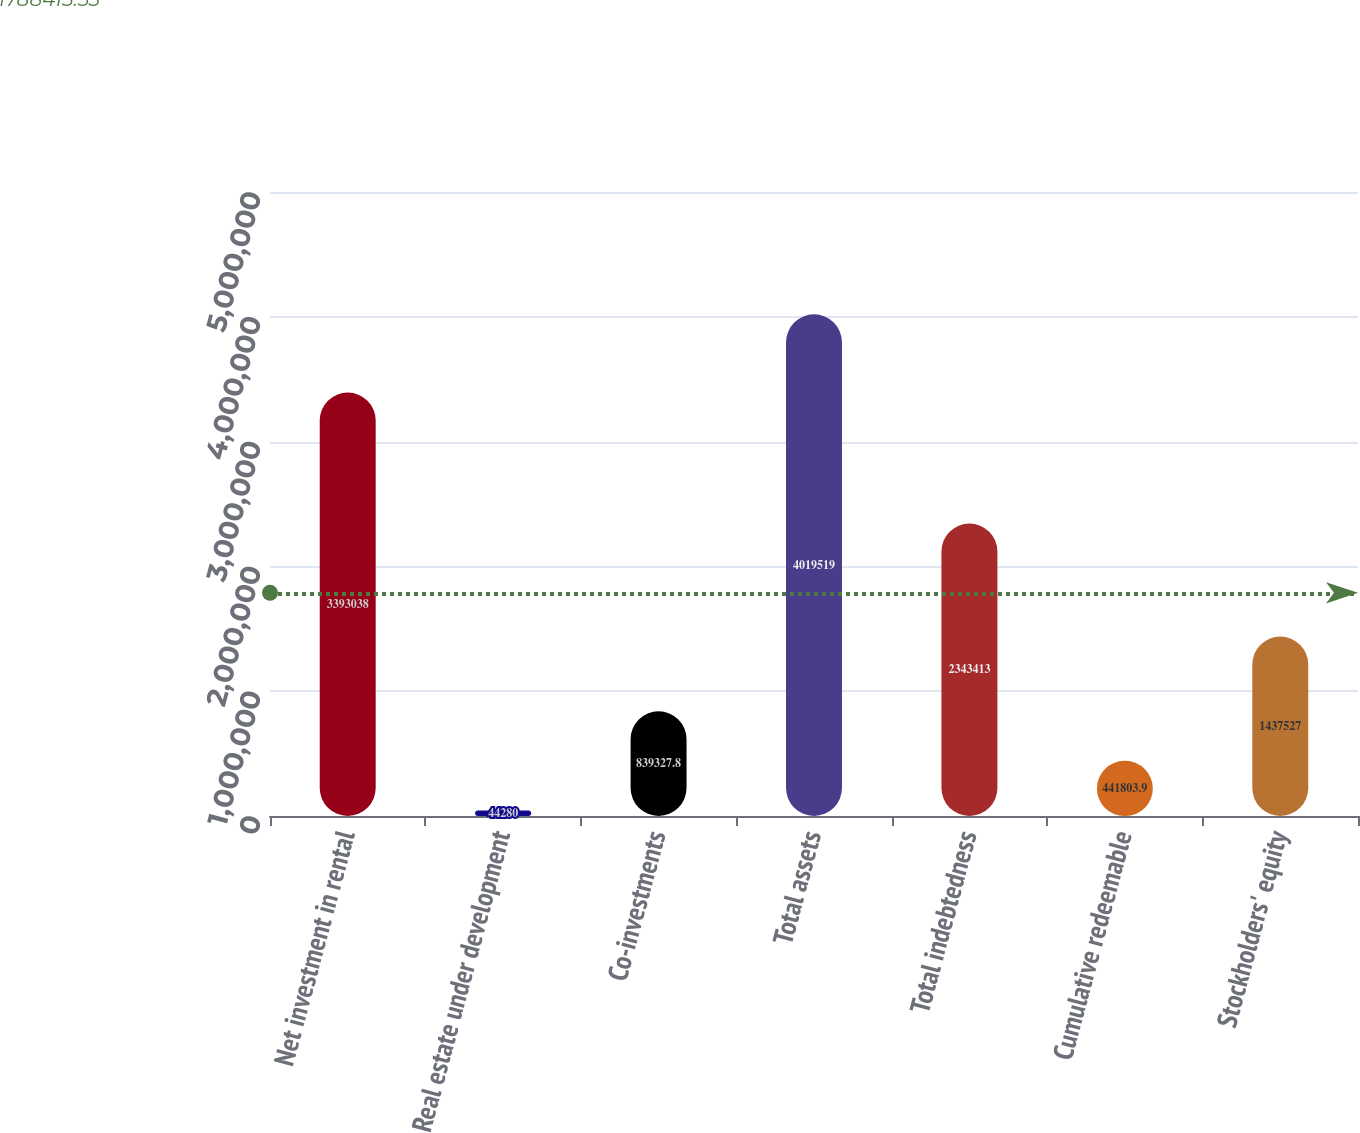<chart> <loc_0><loc_0><loc_500><loc_500><bar_chart><fcel>Net investment in rental<fcel>Real estate under development<fcel>Co-investments<fcel>Total assets<fcel>Total indebtedness<fcel>Cumulative redeemable<fcel>Stockholders' equity<nl><fcel>3.39304e+06<fcel>44280<fcel>839328<fcel>4.01952e+06<fcel>2.34341e+06<fcel>441804<fcel>1.43753e+06<nl></chart> 